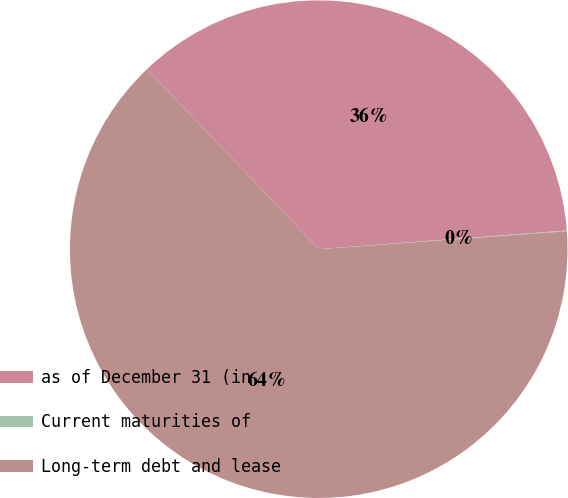<chart> <loc_0><loc_0><loc_500><loc_500><pie_chart><fcel>as of December 31 (in<fcel>Current maturities of<fcel>Long-term debt and lease<nl><fcel>35.92%<fcel>0.05%<fcel>64.02%<nl></chart> 